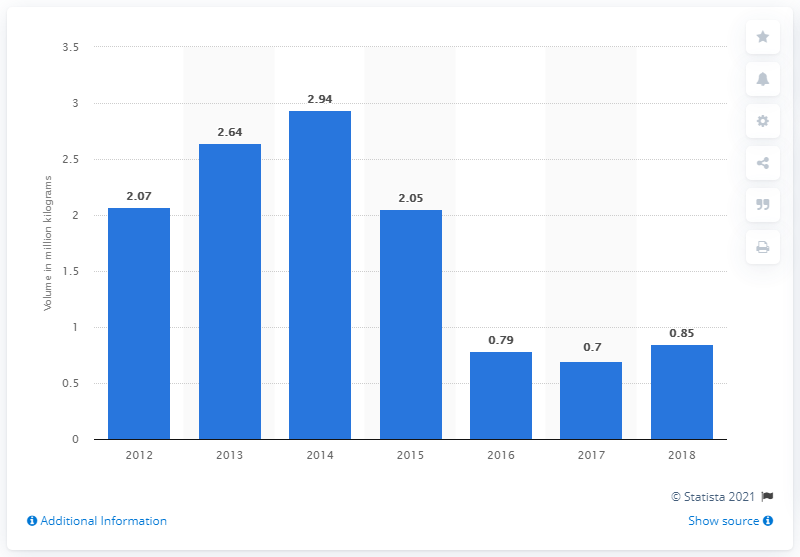Indicate a few pertinent items in this graphic. In 2018, Canada produced approximately 0.85 million metric tons of whey butter. 